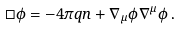Convert formula to latex. <formula><loc_0><loc_0><loc_500><loc_500>\Box \phi = - 4 \pi q n + \nabla _ { \mu } \phi \nabla ^ { \mu } \phi \, .</formula> 